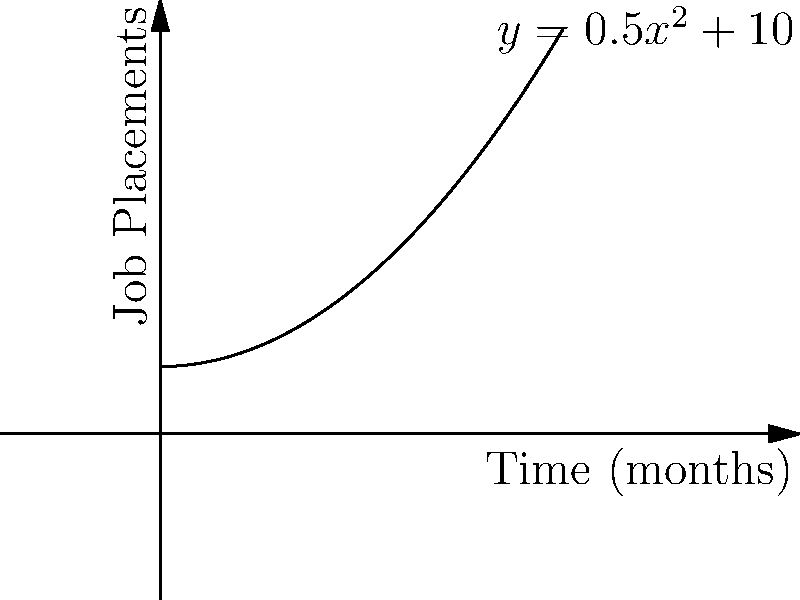As a vocational rehabilitation specialist, you're tracking the success rate of job placements for injured workers over time. The graph shows the relationship between time (in months) and the number of successful job placements. If the curve is represented by the function $y = 0.5x^2 + 10$, what is the rate of change in job placements at the 6-month mark? To find the rate of change at a specific point, we need to calculate the derivative of the function and evaluate it at x = 6.

1) The given function is $y = 0.5x^2 + 10$

2) To find the derivative, we use the power rule:
   $\frac{dy}{dx} = 0.5 \cdot 2x^{2-1} + 0 = x$

3) The derivative function is $\frac{dy}{dx} = x$

4) To find the rate of change at the 6-month mark, we substitute x = 6 into the derivative function:
   $\frac{dy}{dx}|_{x=6} = 6$

5) Therefore, at the 6-month mark, the rate of change in job placements is 6 placements per month.
Answer: 6 placements/month 